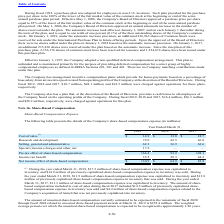From Microchip Technology's financial document, Which years does the table provide information for the details of the Company's share-based compensation expense? The document contains multiple relevant values: 2019, 2018, 2017. From the document: "2019 2018 2017 2019 2018 2017 2019 2018 2017..." Also, What was the weighted average period over which the unearned share-based compensation is expected to be recognized? approximately 1.88 years. The document states: "ased compensation is expected to be recognized is approximately 1.88 years...." Also, What was the cost of sales in 2017? According to the financial document, 18.7 (in millions). The relevant text states: "of Directors. During fiscal 2019, 2018 and 2017, $18.7 million, $48.1 million and $41.5 million were charged against operations for these plans, respectiv..." Also, can you calculate: What was the change in the cost of sales between 2017 and 2018? Based on the calculation: 13.8-18.7, the result is -4.9 (in millions). This is based on the information: "of Directors. During fiscal 2019, 2018 and 2017, $18.7 million, $48.1 million and $41.5 million were charged against operations for these plans, respectiv Cost of sales (1) $ 14.9 $ 13.8 $ 18.7..." The key data points involved are: 13.8, 18.7. Also, How many years did research and development expenses exceed $50 million? Based on the analysis, there are 1 instances. The counting process: 2019. Also, can you calculate: What was the percentage change in the Income tax benefit between 2018 and 2019? To answer this question, I need to perform calculations using the financial data. The calculation is: (35.5-28.3)/28.3, which equals 25.44 (percentage). This is based on the information: "Income tax benefit 35.5 28.3 44.2 Income tax benefit 35.5 28.3 44.2..." The key data points involved are: 28.3, 35.5. 